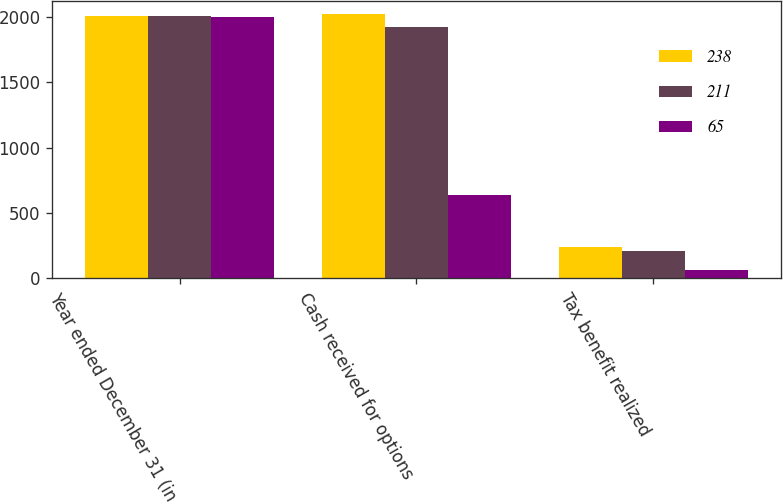Convert chart to OTSL. <chart><loc_0><loc_0><loc_500><loc_500><stacked_bar_chart><ecel><fcel>Year ended December 31 (in<fcel>Cash received for options<fcel>Tax benefit realized<nl><fcel>238<fcel>2007<fcel>2023<fcel>238<nl><fcel>211<fcel>2006<fcel>1924<fcel>211<nl><fcel>65<fcel>2005<fcel>635<fcel>65<nl></chart> 